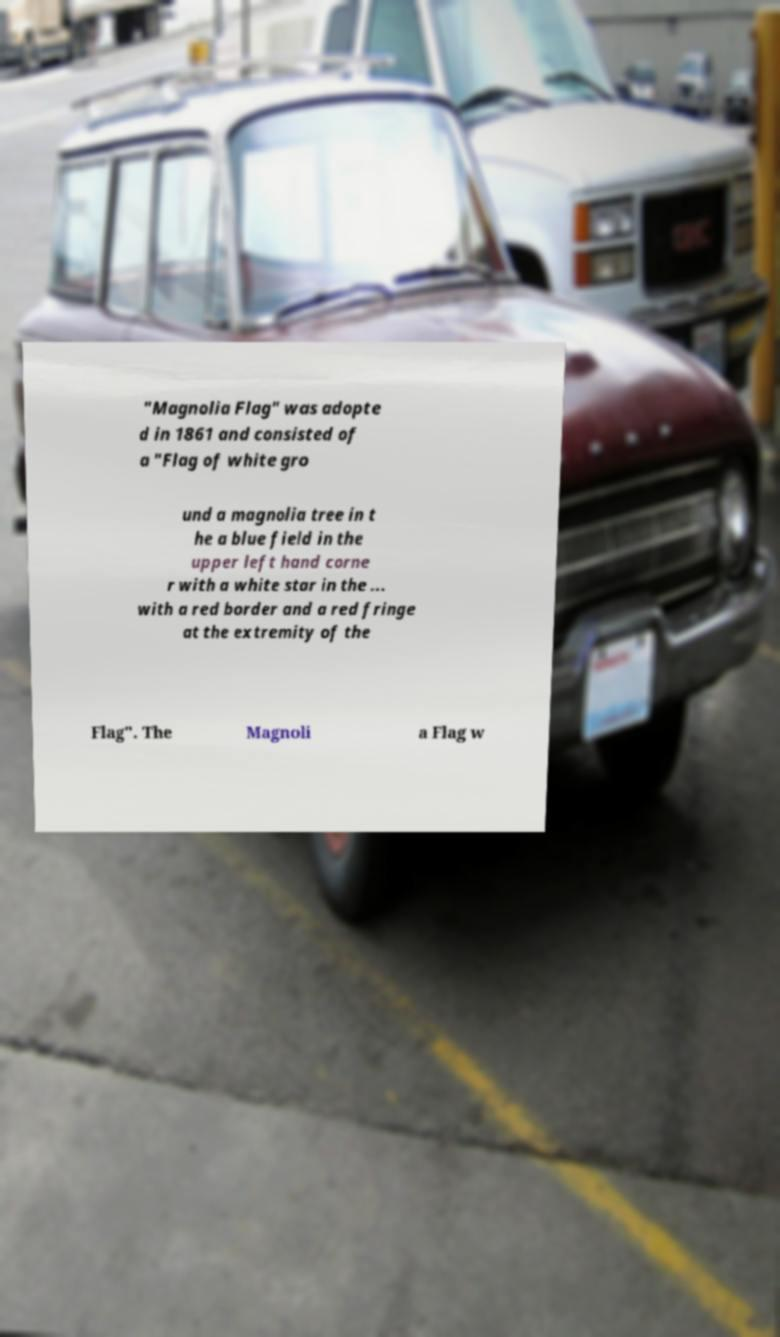For documentation purposes, I need the text within this image transcribed. Could you provide that? "Magnolia Flag" was adopte d in 1861 and consisted of a "Flag of white gro und a magnolia tree in t he a blue field in the upper left hand corne r with a white star in the ... with a red border and a red fringe at the extremity of the Flag". The Magnoli a Flag w 